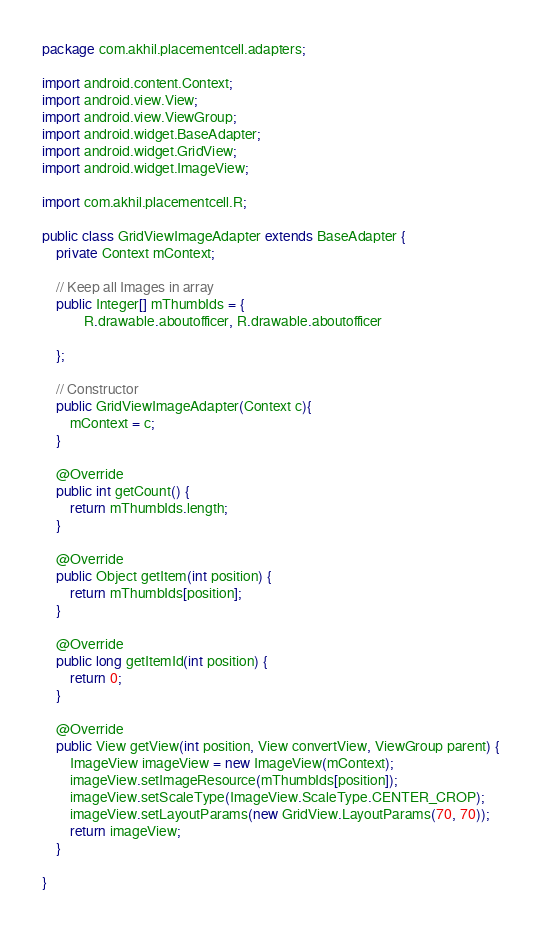<code> <loc_0><loc_0><loc_500><loc_500><_Java_>package com.akhil.placementcell.adapters;

import android.content.Context;
import android.view.View;
import android.view.ViewGroup;
import android.widget.BaseAdapter;
import android.widget.GridView;
import android.widget.ImageView;

import com.akhil.placementcell.R;

public class GridViewImageAdapter extends BaseAdapter {
	private Context mContext;

	// Keep all Images in array
	public Integer[] mThumbIds = {
			R.drawable.aboutofficer, R.drawable.aboutofficer

	};

	// Constructor
	public GridViewImageAdapter(Context c){
		mContext = c;
	}

	@Override
	public int getCount() {
		return mThumbIds.length;
	}

	@Override
	public Object getItem(int position) {
		return mThumbIds[position];
	}

	@Override
	public long getItemId(int position) {
		return 0;
	}

	@Override
	public View getView(int position, View convertView, ViewGroup parent) {
		ImageView imageView = new ImageView(mContext);
		imageView.setImageResource(mThumbIds[position]);
		imageView.setScaleType(ImageView.ScaleType.CENTER_CROP);
		imageView.setLayoutParams(new GridView.LayoutParams(70, 70));
		return imageView;
	}

}</code> 